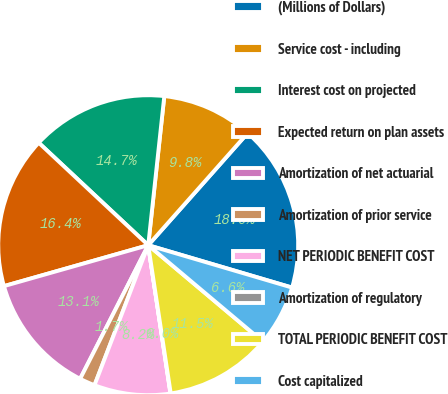Convert chart to OTSL. <chart><loc_0><loc_0><loc_500><loc_500><pie_chart><fcel>(Millions of Dollars)<fcel>Service cost - including<fcel>Interest cost on projected<fcel>Expected return on plan assets<fcel>Amortization of net actuarial<fcel>Amortization of prior service<fcel>NET PERIODIC BENEFIT COST<fcel>Amortization of regulatory<fcel>TOTAL PERIODIC BENEFIT COST<fcel>Cost capitalized<nl><fcel>18.01%<fcel>9.84%<fcel>14.74%<fcel>16.37%<fcel>13.1%<fcel>1.67%<fcel>8.2%<fcel>0.03%<fcel>11.47%<fcel>6.57%<nl></chart> 